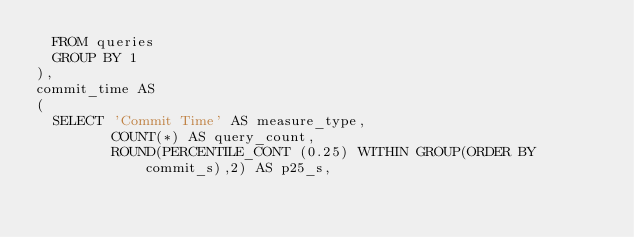<code> <loc_0><loc_0><loc_500><loc_500><_SQL_>  FROM queries
  GROUP BY 1
),
commit_time AS
(
  SELECT 'Commit Time' AS measure_type,
         COUNT(*) AS query_count,
         ROUND(PERCENTILE_CONT (0.25) WITHIN GROUP(ORDER BY commit_s),2) AS p25_s,</code> 